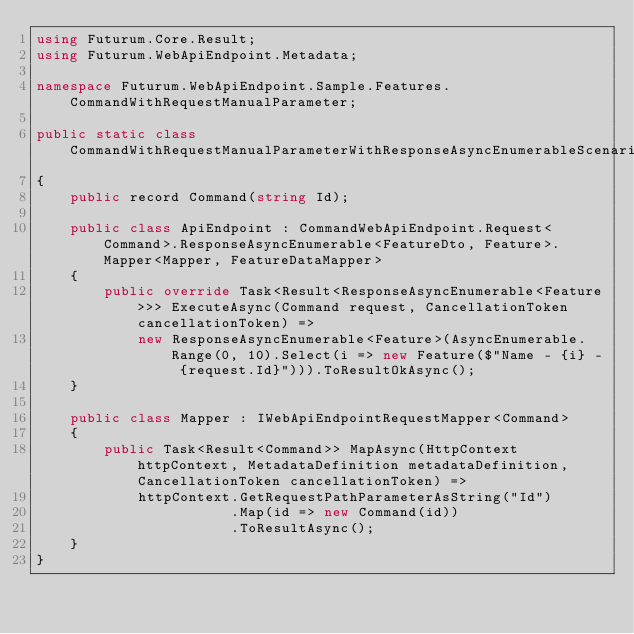<code> <loc_0><loc_0><loc_500><loc_500><_C#_>using Futurum.Core.Result;
using Futurum.WebApiEndpoint.Metadata;

namespace Futurum.WebApiEndpoint.Sample.Features.CommandWithRequestManualParameter;

public static class CommandWithRequestManualParameterWithResponseAsyncEnumerableScenario
{
    public record Command(string Id);

    public class ApiEndpoint : CommandWebApiEndpoint.Request<Command>.ResponseAsyncEnumerable<FeatureDto, Feature>.Mapper<Mapper, FeatureDataMapper>
    {
        public override Task<Result<ResponseAsyncEnumerable<Feature>>> ExecuteAsync(Command request, CancellationToken cancellationToken) =>
            new ResponseAsyncEnumerable<Feature>(AsyncEnumerable.Range(0, 10).Select(i => new Feature($"Name - {i} - {request.Id}"))).ToResultOkAsync();
    }

    public class Mapper : IWebApiEndpointRequestMapper<Command>
    {
        public Task<Result<Command>> MapAsync(HttpContext httpContext, MetadataDefinition metadataDefinition, CancellationToken cancellationToken) =>
            httpContext.GetRequestPathParameterAsString("Id")
                       .Map(id => new Command(id))
                       .ToResultAsync();
    }
}</code> 